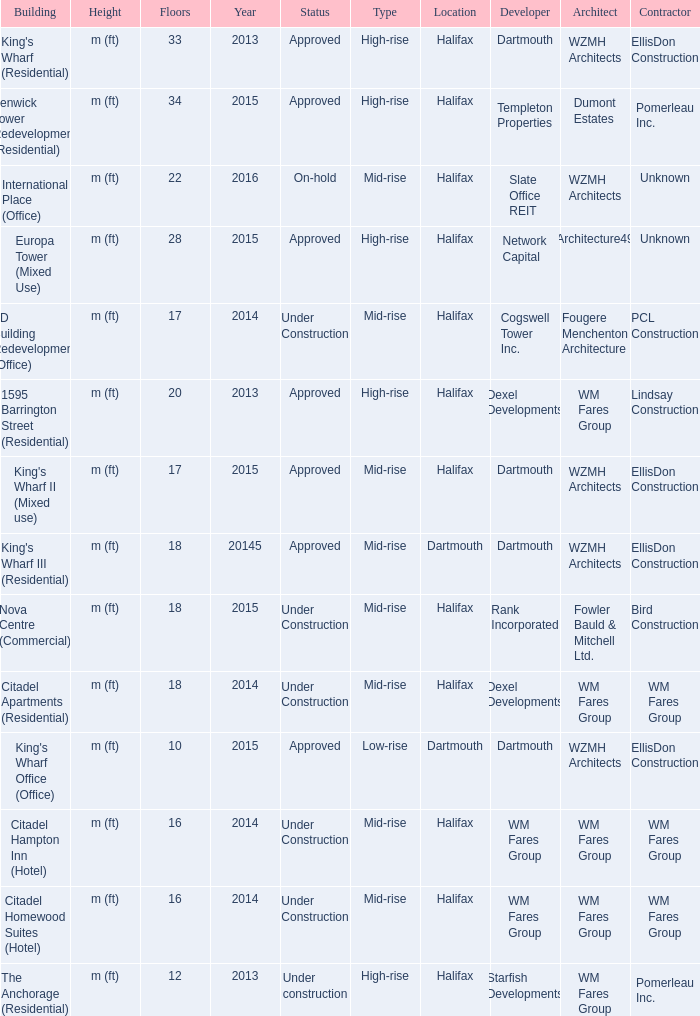What is the status of the building with less than 18 floors and later than 2013? Under Construction, Approved, Approved, Under Construction, Under Construction. 